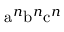<formula> <loc_0><loc_0><loc_500><loc_500>{ a } ^ { n } { b } ^ { n } { c } ^ { n }</formula> 